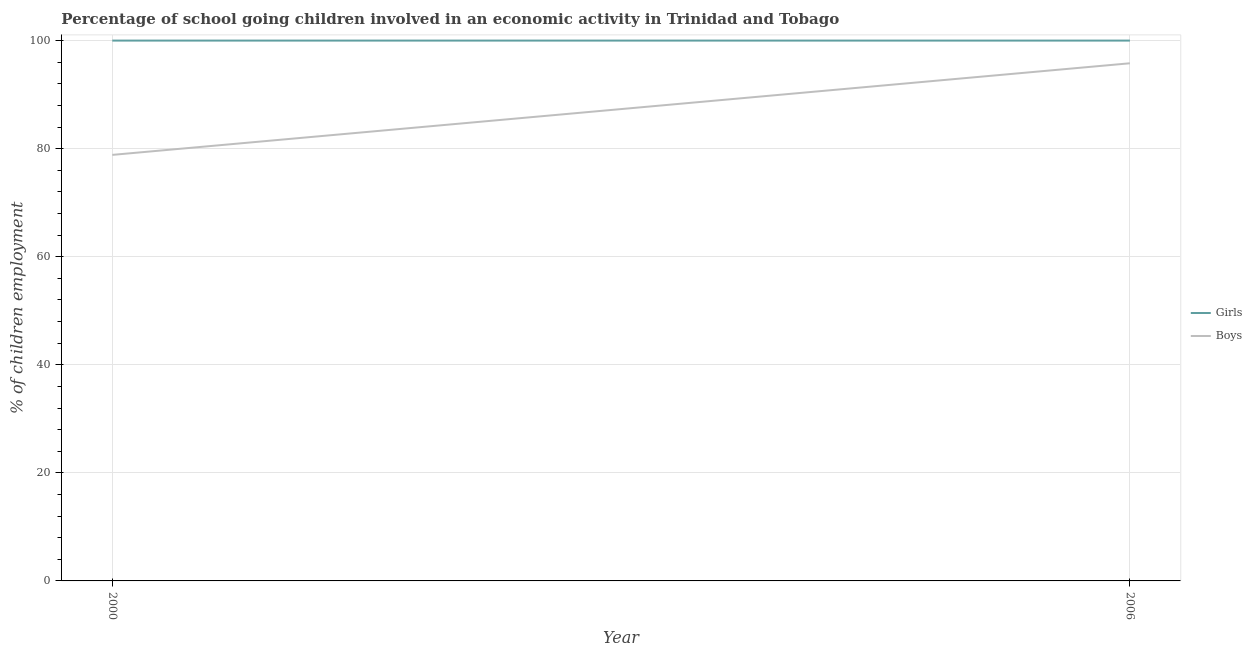Is the number of lines equal to the number of legend labels?
Keep it short and to the point. Yes. What is the percentage of school going boys in 2006?
Your response must be concise. 95.8. Across all years, what is the maximum percentage of school going boys?
Your answer should be very brief. 95.8. Across all years, what is the minimum percentage of school going boys?
Provide a succinct answer. 78.85. In which year was the percentage of school going girls maximum?
Keep it short and to the point. 2000. What is the total percentage of school going girls in the graph?
Ensure brevity in your answer.  200. What is the difference between the percentage of school going boys in 2000 and that in 2006?
Ensure brevity in your answer.  -16.95. What is the difference between the percentage of school going girls in 2006 and the percentage of school going boys in 2000?
Ensure brevity in your answer.  21.15. What is the average percentage of school going boys per year?
Provide a succinct answer. 87.32. In the year 2000, what is the difference between the percentage of school going boys and percentage of school going girls?
Give a very brief answer. -21.15. Is the percentage of school going boys in 2000 less than that in 2006?
Make the answer very short. Yes. Does the percentage of school going girls monotonically increase over the years?
Offer a very short reply. No. What is the difference between two consecutive major ticks on the Y-axis?
Give a very brief answer. 20. Does the graph contain any zero values?
Give a very brief answer. No. Where does the legend appear in the graph?
Provide a succinct answer. Center right. How many legend labels are there?
Offer a very short reply. 2. What is the title of the graph?
Make the answer very short. Percentage of school going children involved in an economic activity in Trinidad and Tobago. What is the label or title of the Y-axis?
Make the answer very short. % of children employment. What is the % of children employment in Boys in 2000?
Provide a succinct answer. 78.85. What is the % of children employment in Girls in 2006?
Make the answer very short. 100. What is the % of children employment of Boys in 2006?
Your answer should be very brief. 95.8. Across all years, what is the maximum % of children employment of Girls?
Make the answer very short. 100. Across all years, what is the maximum % of children employment in Boys?
Ensure brevity in your answer.  95.8. Across all years, what is the minimum % of children employment of Girls?
Offer a very short reply. 100. Across all years, what is the minimum % of children employment in Boys?
Give a very brief answer. 78.85. What is the total % of children employment of Boys in the graph?
Your answer should be very brief. 174.65. What is the difference between the % of children employment of Girls in 2000 and that in 2006?
Ensure brevity in your answer.  0. What is the difference between the % of children employment in Boys in 2000 and that in 2006?
Your answer should be very brief. -16.95. What is the difference between the % of children employment of Girls in 2000 and the % of children employment of Boys in 2006?
Ensure brevity in your answer.  4.2. What is the average % of children employment in Boys per year?
Give a very brief answer. 87.32. In the year 2000, what is the difference between the % of children employment in Girls and % of children employment in Boys?
Ensure brevity in your answer.  21.15. What is the ratio of the % of children employment of Girls in 2000 to that in 2006?
Your answer should be compact. 1. What is the ratio of the % of children employment of Boys in 2000 to that in 2006?
Ensure brevity in your answer.  0.82. What is the difference between the highest and the second highest % of children employment in Boys?
Offer a very short reply. 16.95. What is the difference between the highest and the lowest % of children employment in Boys?
Ensure brevity in your answer.  16.95. 